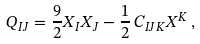<formula> <loc_0><loc_0><loc_500><loc_500>Q _ { I J } = \frac { 9 } { 2 } X _ { I } X _ { J } - \frac { 1 } { 2 } \, C _ { I J K } X ^ { K } \, ,</formula> 